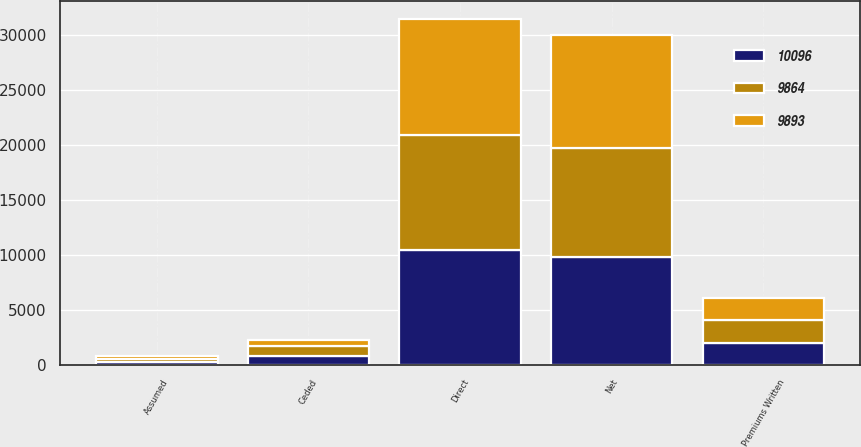Convert chart to OTSL. <chart><loc_0><loc_0><loc_500><loc_500><stacked_bar_chart><ecel><fcel>Premiums Written<fcel>Direct<fcel>Assumed<fcel>Ceded<fcel>Net<nl><fcel>9893<fcel>2014<fcel>10571<fcel>275<fcel>602<fcel>10244<nl><fcel>9864<fcel>2013<fcel>10564<fcel>247<fcel>882<fcel>9929<nl><fcel>10096<fcel>2012<fcel>10405<fcel>230<fcel>788<fcel>9847<nl></chart> 